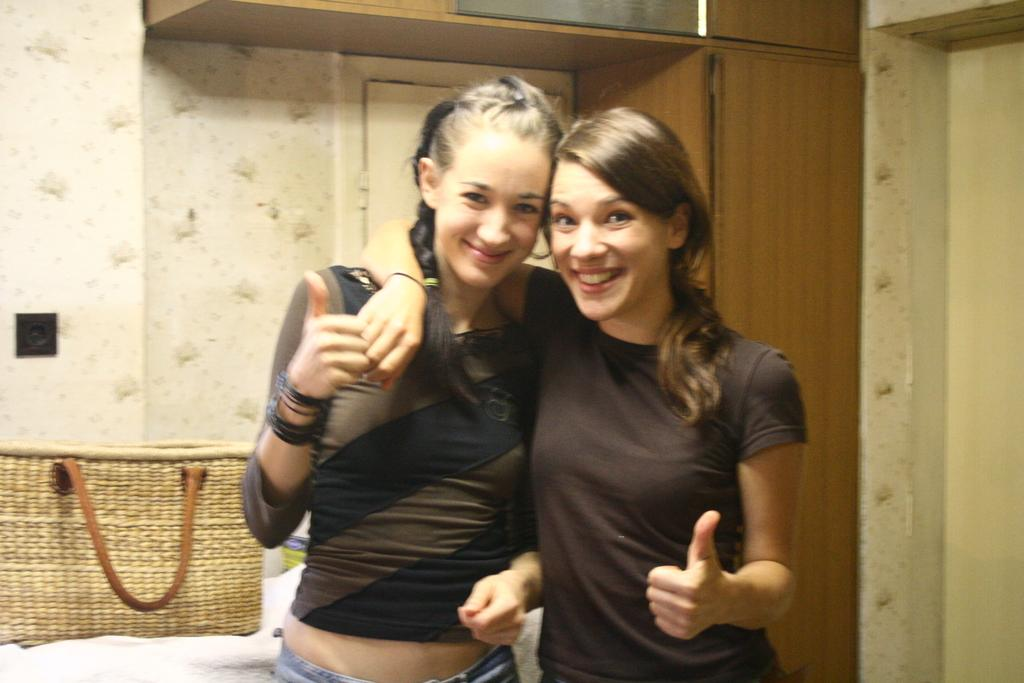How many women are in the image? There are two women in the image. What expression do the women have? The women are smiling. What object can be seen in the image besides the women? There is a bag in the image. What can be seen in the background of the image? There is a wall, cupboards, and a door in the background of the image. What type of shirt is the band wearing in the image? There is no band present in the image, so it is not possible to determine what type of shirt they might be wearing. 